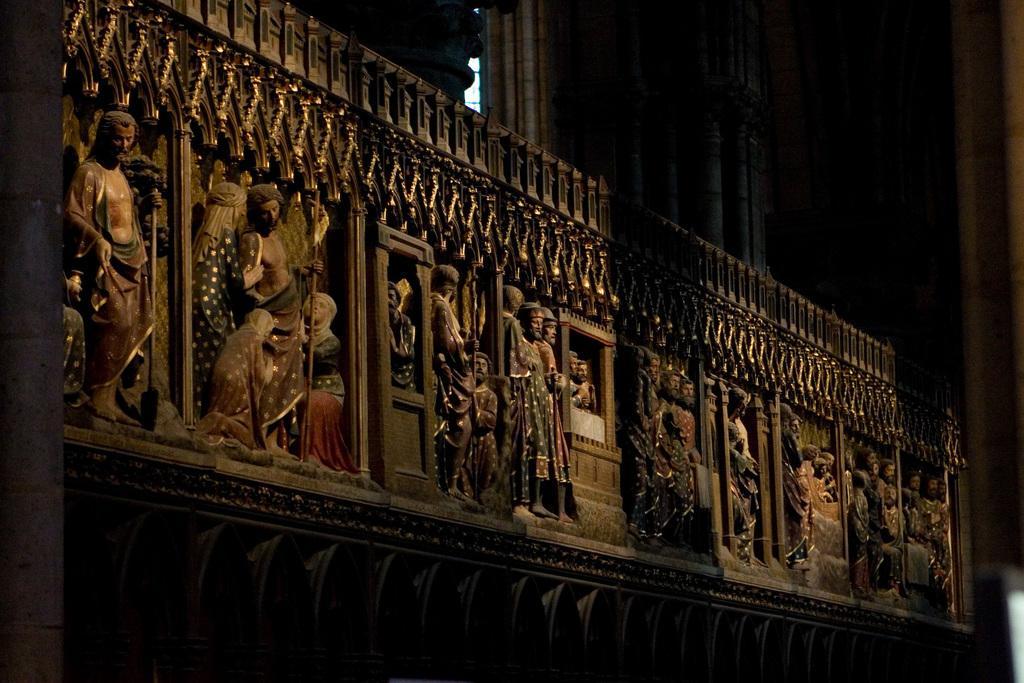Can you describe this image briefly? Here we can see sculptures on a platform. In the background the image is not clear. 